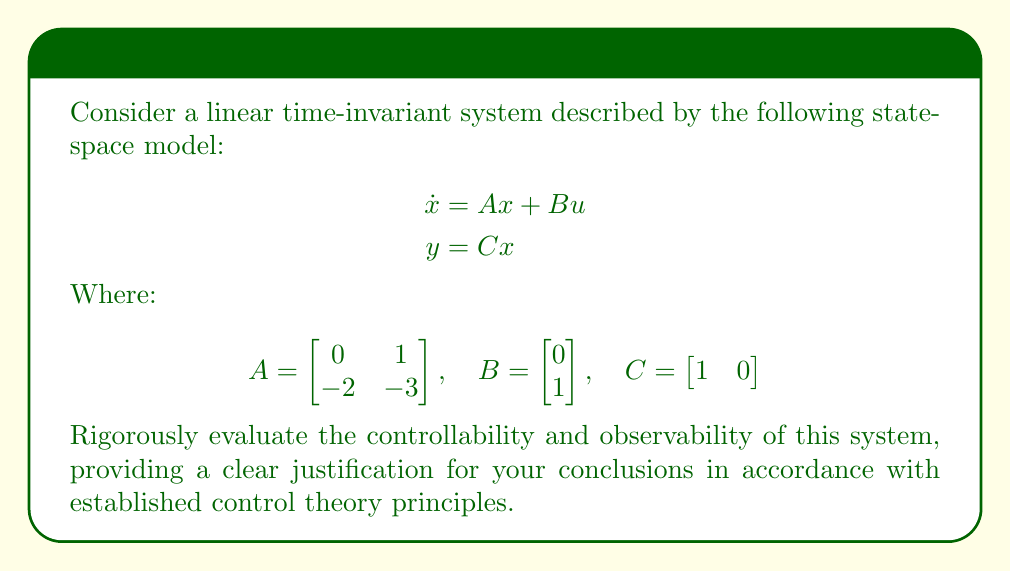Solve this math problem. To evaluate the controllability and observability of the given state-space model, we will follow a systematic approach based on established control theory principles:

1. Controllability:
   a) Form the controllability matrix: $\mathcal{C} = [B \quad AB]$
   b) Calculate $AB$:
      $$AB = \begin{bmatrix} 0 & 1 \\ -2 & -3 \end{bmatrix} \begin{bmatrix} 0 \\ 1 \end{bmatrix} = \begin{bmatrix} 1 \\ -3 \end{bmatrix}$$
   c) Construct $\mathcal{C}$:
      $$\mathcal{C} = \left[\begin{array}{cc|cc} 0 & 1 \\ 1 & -3 \end{array}\right]$$
   d) Calculate $\text{rank}(\mathcal{C})$:
      The determinant of $\mathcal{C}$ is $-1 \neq 0$, so $\text{rank}(\mathcal{C}) = 2$
   e) Conclusion: Since $\text{rank}(\mathcal{C}) = 2$, which is equal to the number of states, the system is controllable.

2. Observability:
   a) Form the observability matrix: $\mathcal{O} = \begin{bmatrix} C \\ CA \end{bmatrix}$
   b) Calculate $CA$:
      $$CA = \begin{bmatrix} 1 & 0 \end{bmatrix} \begin{bmatrix} 0 & 1 \\ -2 & -3 \end{bmatrix} = \begin{bmatrix} 0 & 1 \end{bmatrix}$$
   c) Construct $\mathcal{O}$:
      $$\mathcal{O} = \begin{bmatrix} 1 & 0 \\ 0 & 1 \end{bmatrix}$$
   d) Calculate $\text{rank}(\mathcal{O})$:
      The determinant of $\mathcal{O}$ is $1 \neq 0$, so $\text{rank}(\mathcal{O}) = 2$
   e) Conclusion: Since $\text{rank}(\mathcal{O}) = 2$, which is equal to the number of states, the system is observable.
Answer: The system is both controllable and observable. 